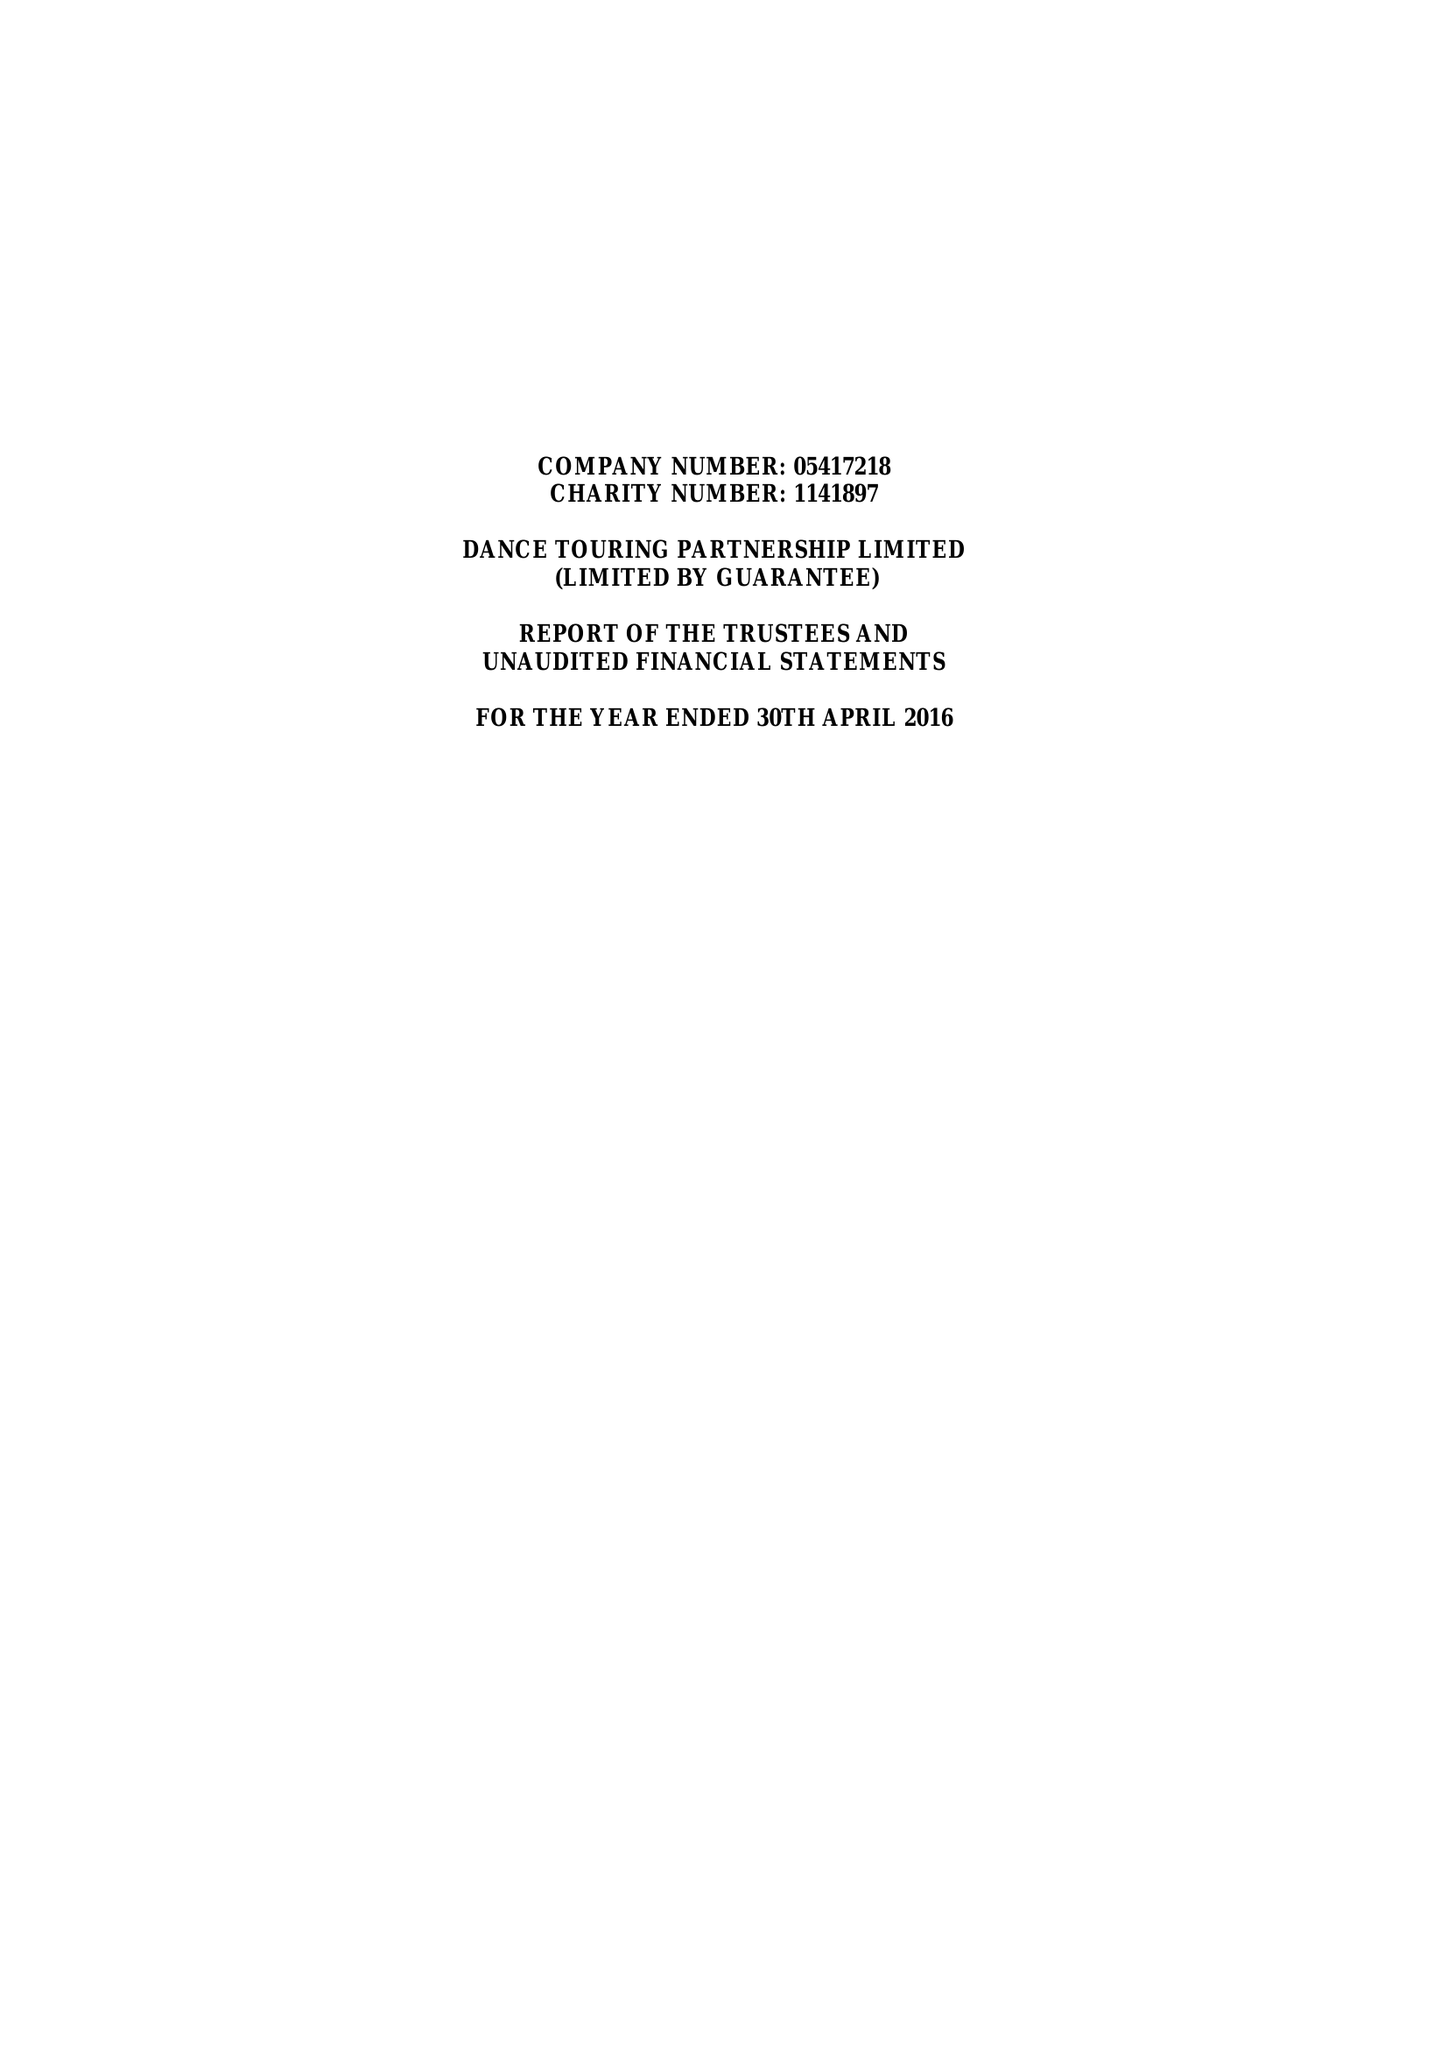What is the value for the address__street_line?
Answer the question using a single word or phrase. None 